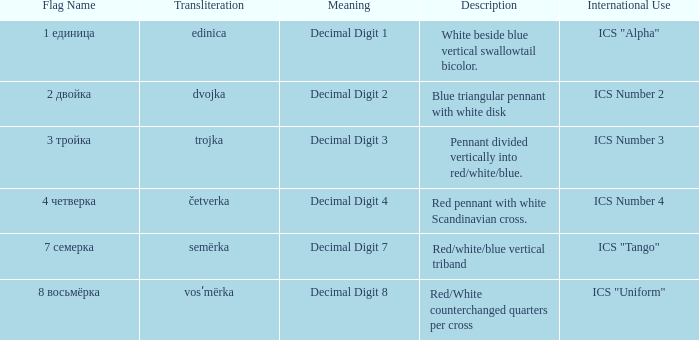What are the meanings of the flag whose name transliterates to semërka? Decimal Digit 7. 